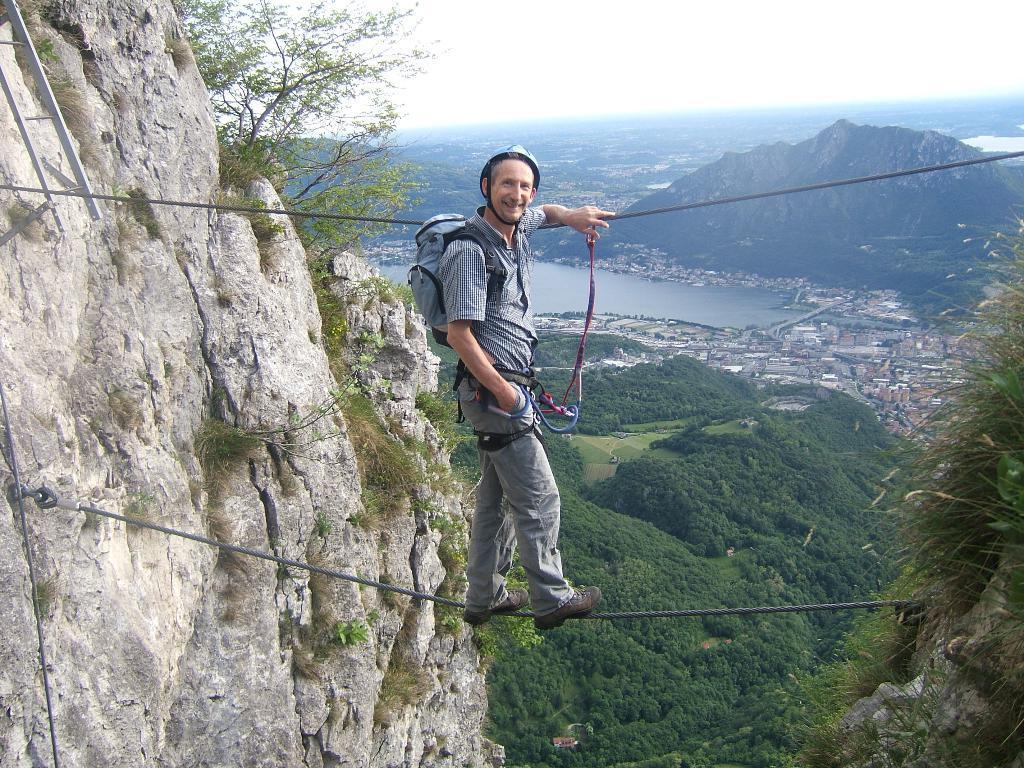Can you describe this image briefly? In this picture, we see the man who is wearing the blue backpack is walking on the rope. He is smiling and he might be posing for the photo. On the left side, we see the rocks, a ladder and the trees. On the right side, we see the grass and a hill. IN the middle, we see the trees. Beside that, we see the buildings and the water. This water might be in the lake. There are trees, hills and the buildings in the background. At the top, we see the sky. 